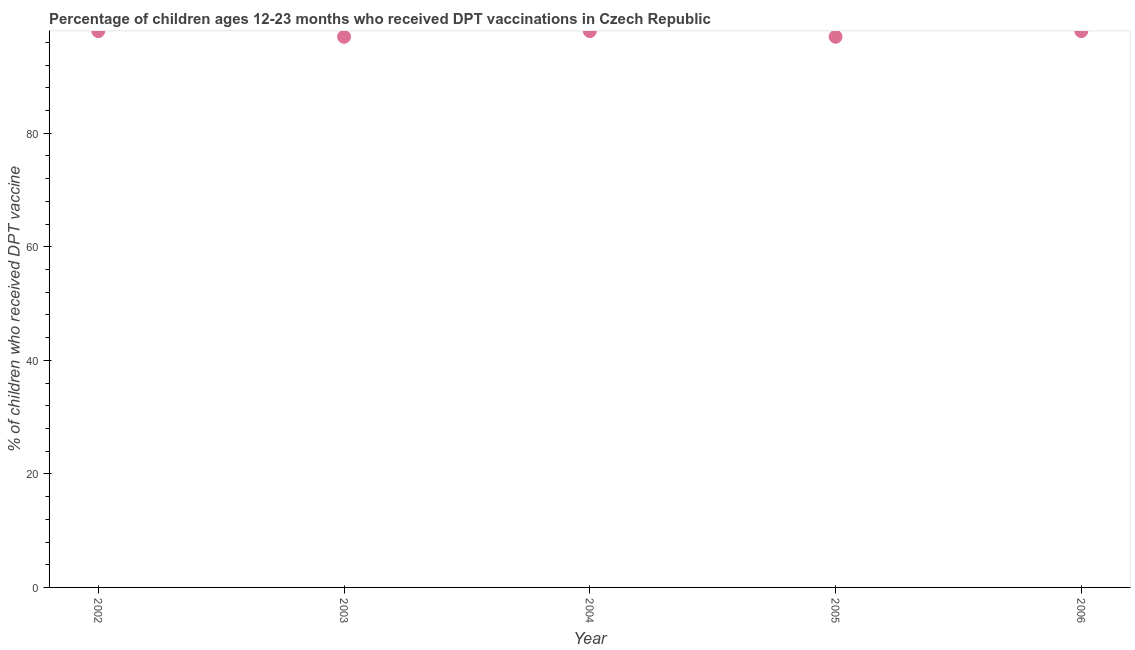What is the percentage of children who received dpt vaccine in 2002?
Provide a short and direct response. 98. Across all years, what is the maximum percentage of children who received dpt vaccine?
Offer a very short reply. 98. Across all years, what is the minimum percentage of children who received dpt vaccine?
Give a very brief answer. 97. In which year was the percentage of children who received dpt vaccine maximum?
Offer a very short reply. 2002. In which year was the percentage of children who received dpt vaccine minimum?
Keep it short and to the point. 2003. What is the sum of the percentage of children who received dpt vaccine?
Your answer should be compact. 488. What is the difference between the percentage of children who received dpt vaccine in 2003 and 2004?
Your answer should be compact. -1. What is the average percentage of children who received dpt vaccine per year?
Offer a terse response. 97.6. What is the ratio of the percentage of children who received dpt vaccine in 2002 to that in 2005?
Offer a terse response. 1.01. What is the difference between the highest and the second highest percentage of children who received dpt vaccine?
Your answer should be very brief. 0. Is the sum of the percentage of children who received dpt vaccine in 2002 and 2005 greater than the maximum percentage of children who received dpt vaccine across all years?
Offer a terse response. Yes. What is the difference between the highest and the lowest percentage of children who received dpt vaccine?
Ensure brevity in your answer.  1. In how many years, is the percentage of children who received dpt vaccine greater than the average percentage of children who received dpt vaccine taken over all years?
Your answer should be compact. 3. Does the percentage of children who received dpt vaccine monotonically increase over the years?
Your response must be concise. No. How many years are there in the graph?
Make the answer very short. 5. Does the graph contain any zero values?
Ensure brevity in your answer.  No. What is the title of the graph?
Offer a very short reply. Percentage of children ages 12-23 months who received DPT vaccinations in Czech Republic. What is the label or title of the Y-axis?
Provide a short and direct response. % of children who received DPT vaccine. What is the % of children who received DPT vaccine in 2002?
Provide a succinct answer. 98. What is the % of children who received DPT vaccine in 2003?
Make the answer very short. 97. What is the % of children who received DPT vaccine in 2005?
Your answer should be compact. 97. What is the difference between the % of children who received DPT vaccine in 2002 and 2004?
Keep it short and to the point. 0. What is the difference between the % of children who received DPT vaccine in 2003 and 2004?
Provide a succinct answer. -1. What is the difference between the % of children who received DPT vaccine in 2003 and 2005?
Make the answer very short. 0. What is the difference between the % of children who received DPT vaccine in 2003 and 2006?
Provide a succinct answer. -1. What is the difference between the % of children who received DPT vaccine in 2004 and 2005?
Ensure brevity in your answer.  1. What is the difference between the % of children who received DPT vaccine in 2004 and 2006?
Provide a short and direct response. 0. What is the ratio of the % of children who received DPT vaccine in 2002 to that in 2003?
Provide a succinct answer. 1.01. What is the ratio of the % of children who received DPT vaccine in 2002 to that in 2004?
Offer a terse response. 1. What is the ratio of the % of children who received DPT vaccine in 2003 to that in 2005?
Keep it short and to the point. 1. What is the ratio of the % of children who received DPT vaccine in 2003 to that in 2006?
Ensure brevity in your answer.  0.99. What is the ratio of the % of children who received DPT vaccine in 2004 to that in 2006?
Make the answer very short. 1. 